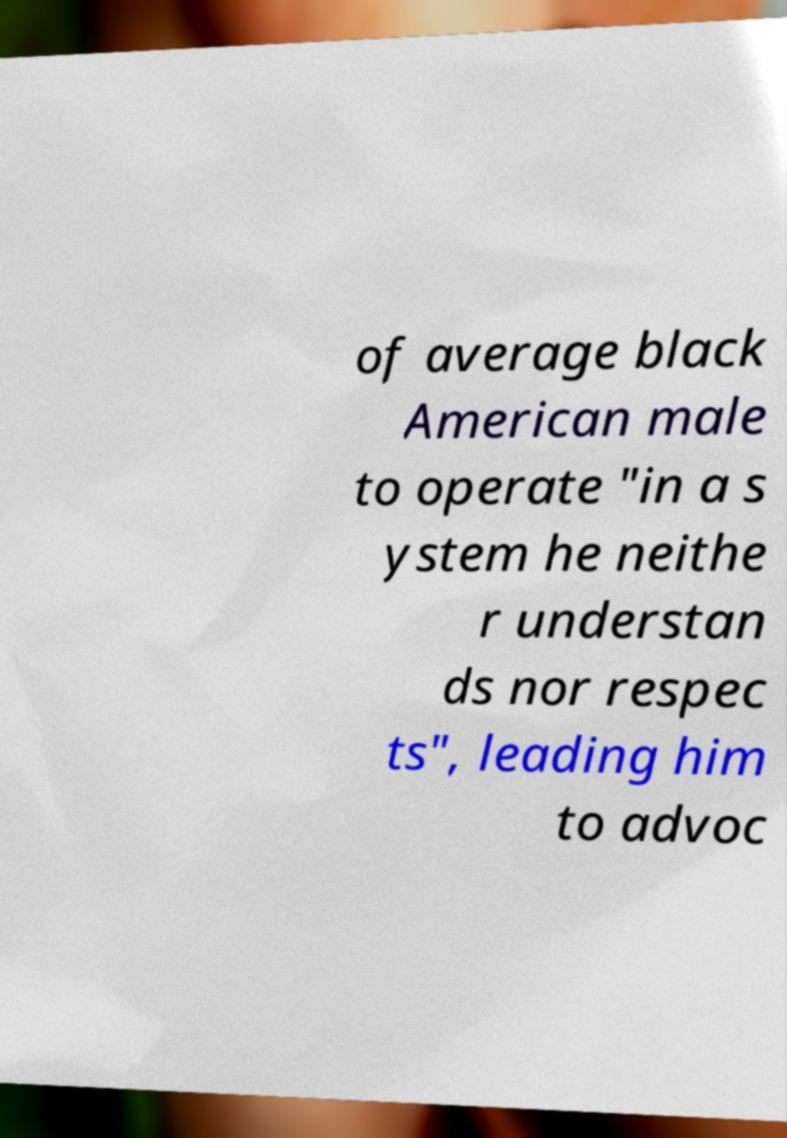I need the written content from this picture converted into text. Can you do that? of average black American male to operate "in a s ystem he neithe r understan ds nor respec ts", leading him to advoc 